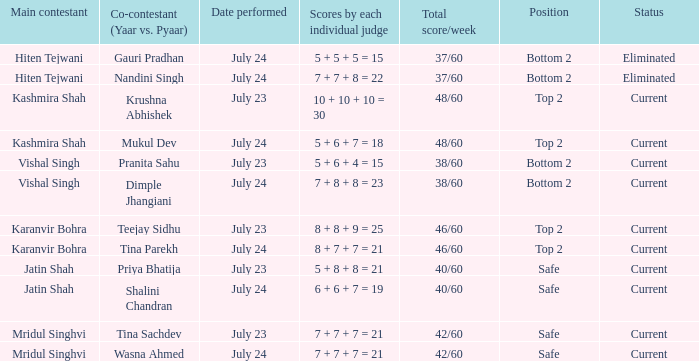What is Tina Sachdev's position? Safe. 